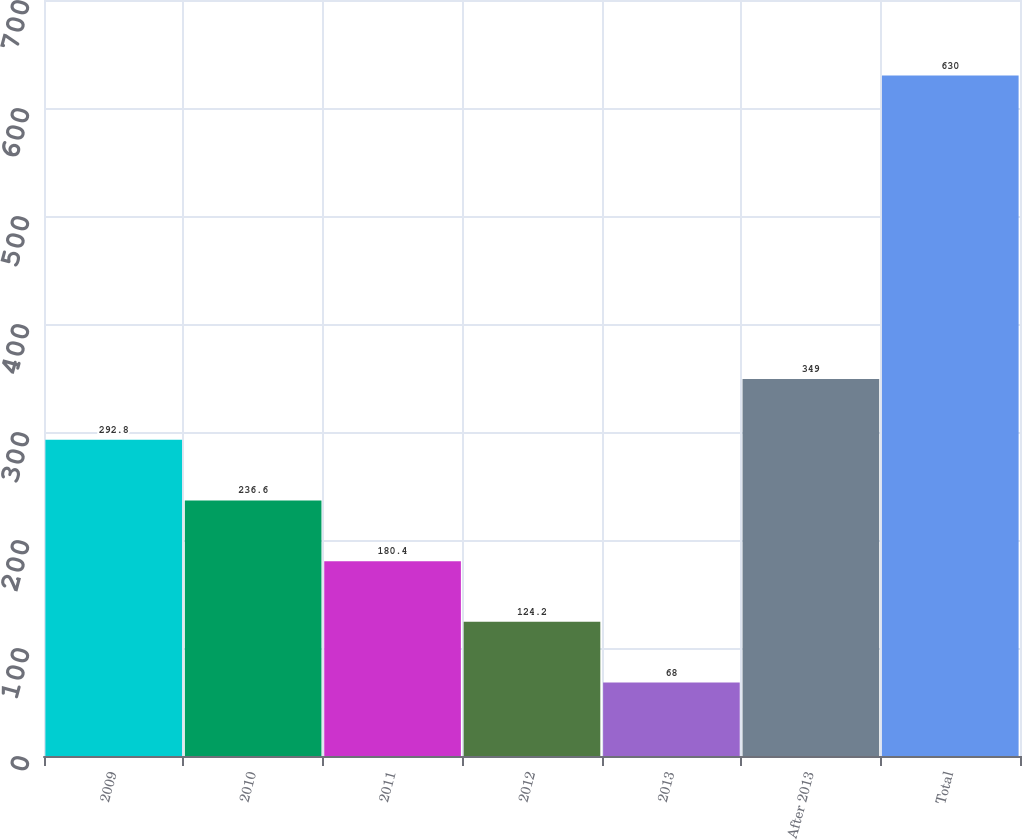Convert chart to OTSL. <chart><loc_0><loc_0><loc_500><loc_500><bar_chart><fcel>2009<fcel>2010<fcel>2011<fcel>2012<fcel>2013<fcel>After 2013<fcel>Total<nl><fcel>292.8<fcel>236.6<fcel>180.4<fcel>124.2<fcel>68<fcel>349<fcel>630<nl></chart> 